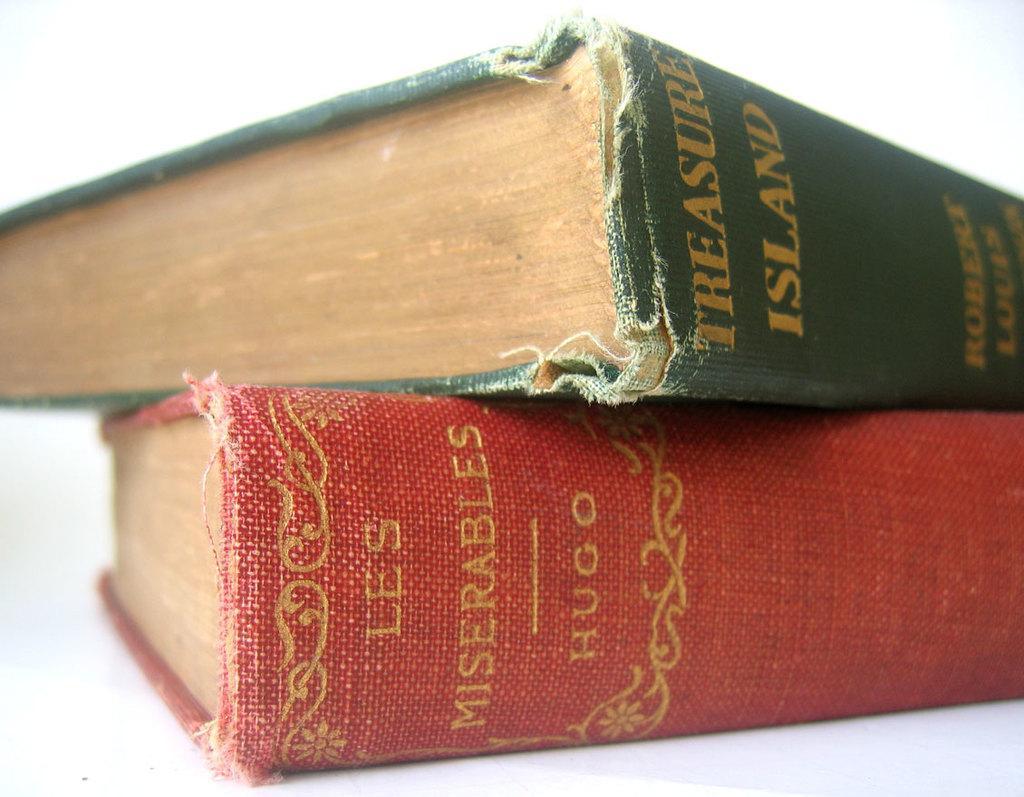Can you describe this image briefly? In the picture we can see two books, one is with red color cover and one is with green color cover on top of it. 